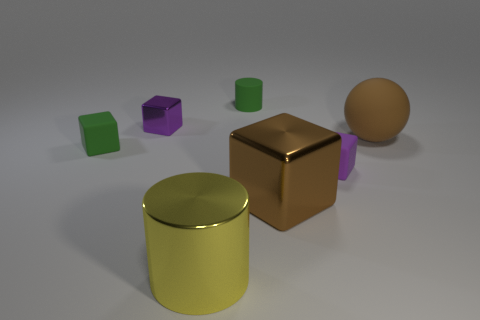There is a matte thing that is the same color as the small metallic block; what size is it?
Your answer should be very brief. Small. Is there anything else that has the same size as the brown matte thing?
Keep it short and to the point. Yes. The green matte thing that is in front of the metal thing that is to the left of the shiny cylinder is what shape?
Give a very brief answer. Cube. Is the number of yellow metallic blocks less than the number of tiny blocks?
Offer a terse response. Yes. There is a cube that is both behind the big brown metallic block and right of the green cylinder; what is its size?
Your response must be concise. Small. Is the size of the purple metal object the same as the purple matte block?
Your answer should be compact. Yes. There is a matte cube that is right of the large yellow cylinder; is its color the same as the small metal block?
Offer a very short reply. Yes. There is a small green matte cylinder; how many rubber cubes are on the right side of it?
Offer a very short reply. 1. Is the number of brown objects greater than the number of brown rubber objects?
Offer a terse response. Yes. There is a thing that is both behind the rubber sphere and to the left of the large yellow object; what shape is it?
Make the answer very short. Cube. 